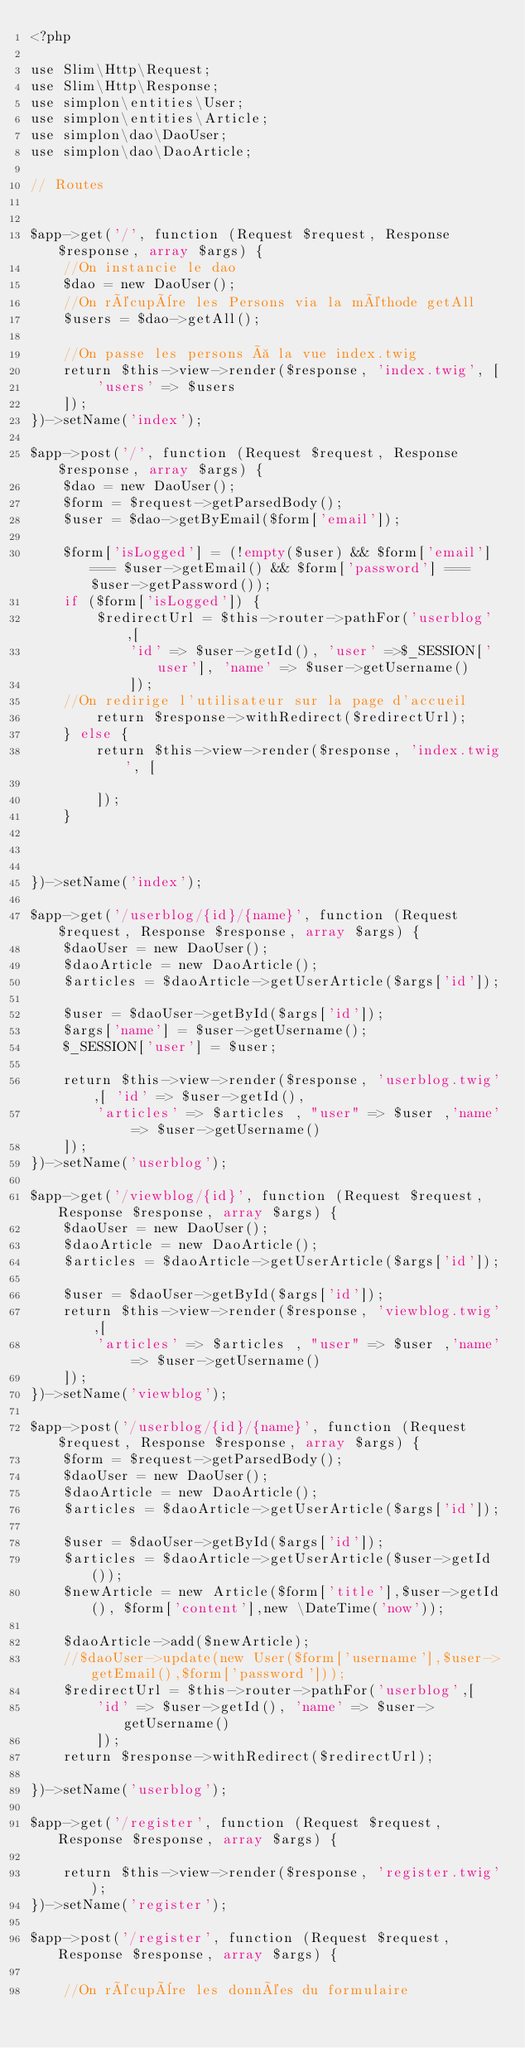<code> <loc_0><loc_0><loc_500><loc_500><_PHP_><?php

use Slim\Http\Request;
use Slim\Http\Response;
use simplon\entities\User;
use simplon\entities\Article;
use simplon\dao\DaoUser;
use simplon\dao\DaoArticle;

// Routes


$app->get('/', function (Request $request, Response $response, array $args) {
    //On instancie le dao
    $dao = new DaoUser();
    //On récupère les Persons via la méthode getAll
    $users = $dao->getAll();
    
    //On passe les persons à la vue index.twig
    return $this->view->render($response, 'index.twig', [
        'users' => $users
    ]);
})->setName('index');

$app->post('/', function (Request $request, Response $response, array $args) {
    $dao = new DaoUser();
    $form = $request->getParsedBody();
    $user = $dao->getByEmail($form['email']);
   
    $form['isLogged'] = (!empty($user) && $form['email'] === $user->getEmail() && $form['password'] === $user->getPassword());
    if ($form['isLogged']) {
        $redirectUrl = $this->router->pathFor('userblog',[
            'id' => $user->getId(), 'user' =>$_SESSION['user'], 'name' => $user->getUsername()
            ]);
    //On redirige l'utilisateur sur la page d'accueil
        return $response->withRedirect($redirectUrl);
    } else {
        return $this->view->render($response, 'index.twig', [
           
        ]);
    }

    
    
})->setName('index');

$app->get('/userblog/{id}/{name}', function (Request $request, Response $response, array $args) {
    $daoUser = new DaoUser();
    $daoArticle = new DaoArticle();
    $articles = $daoArticle->getUserArticle($args['id']);

    $user = $daoUser->getById($args['id']);
    $args['name'] = $user->getUsername();
    $_SESSION['user'] = $user;
    
    return $this->view->render($response, 'userblog.twig',[ 'id' => $user->getId(),
        'articles' => $articles , "user" => $user ,'name' => $user->getUsername()
    ]);
})->setName('userblog');

$app->get('/viewblog/{id}', function (Request $request, Response $response, array $args) {
    $daoUser = new DaoUser();
    $daoArticle = new DaoArticle();
    $articles = $daoArticle->getUserArticle($args['id']);

    $user = $daoUser->getById($args['id']);
    return $this->view->render($response, 'viewblog.twig',[
        'articles' => $articles , "user" => $user ,'name' => $user->getUsername()
    ]);
})->setName('viewblog');

$app->post('/userblog/{id}/{name}', function (Request $request, Response $response, array $args) {
    $form = $request->getParsedBody();
    $daoUser = new DaoUser();
    $daoArticle = new DaoArticle();
    $articles = $daoArticle->getUserArticle($args['id']);
    
    $user = $daoUser->getById($args['id']);
    $articles = $daoArticle->getUserArticle($user->getId());
    $newArticle = new Article($form['title'],$user->getId(), $form['content'],new \DateTime('now'));
    
    $daoArticle->add($newArticle);
    //$daoUser->update(new User($form['username'],$user->getEmail(),$form['password']));
    $redirectUrl = $this->router->pathFor('userblog',[
        'id' => $user->getId(), 'name' => $user->getUsername()
        ]);
    return $response->withRedirect($redirectUrl);
    
})->setName('userblog');

$app->get('/register', function (Request $request, Response $response, array $args) {

    return $this->view->render($response, 'register.twig');
})->setName('register');

$app->post('/register', function (Request $request, Response $response, array $args) {

    //On récupère les données du formulaire</code> 